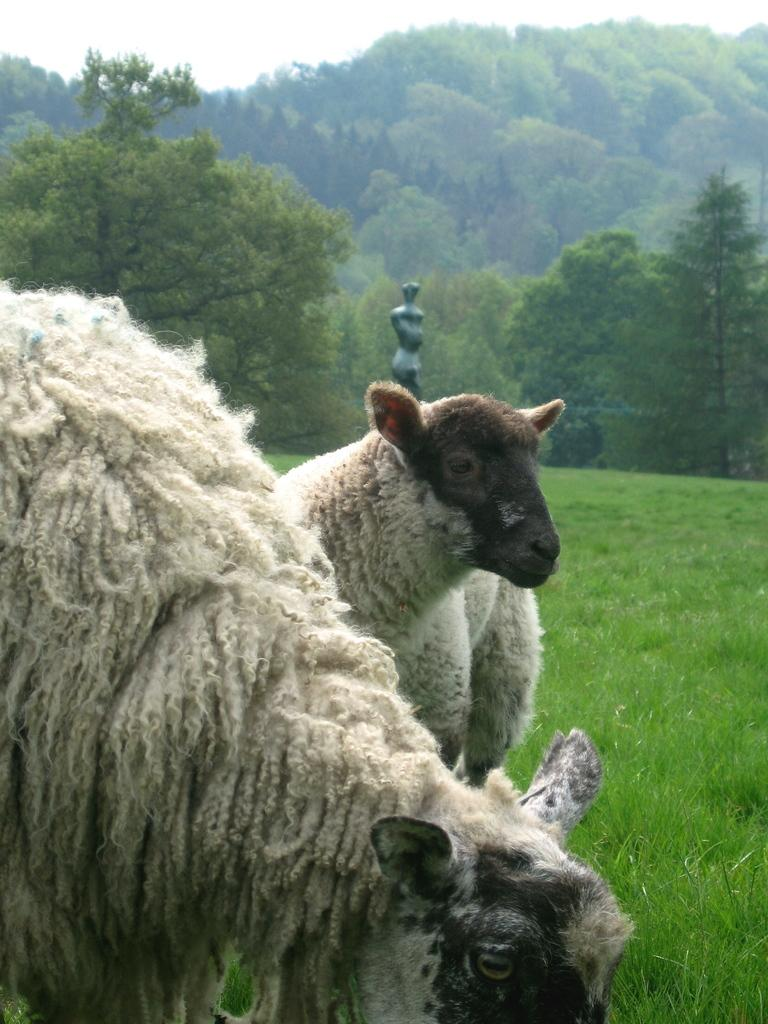How many sheep are in the image? There are two sheep in the image. Where are the sheep located? The sheep are on the grass. What can be seen in the background of the image? There is a pole, trees, and the sky visible in the background of the image. What type of prose can be seen in the image? There is no prose present in the image; it features two sheep on the grass with a background of a pole, trees, and the sky. 